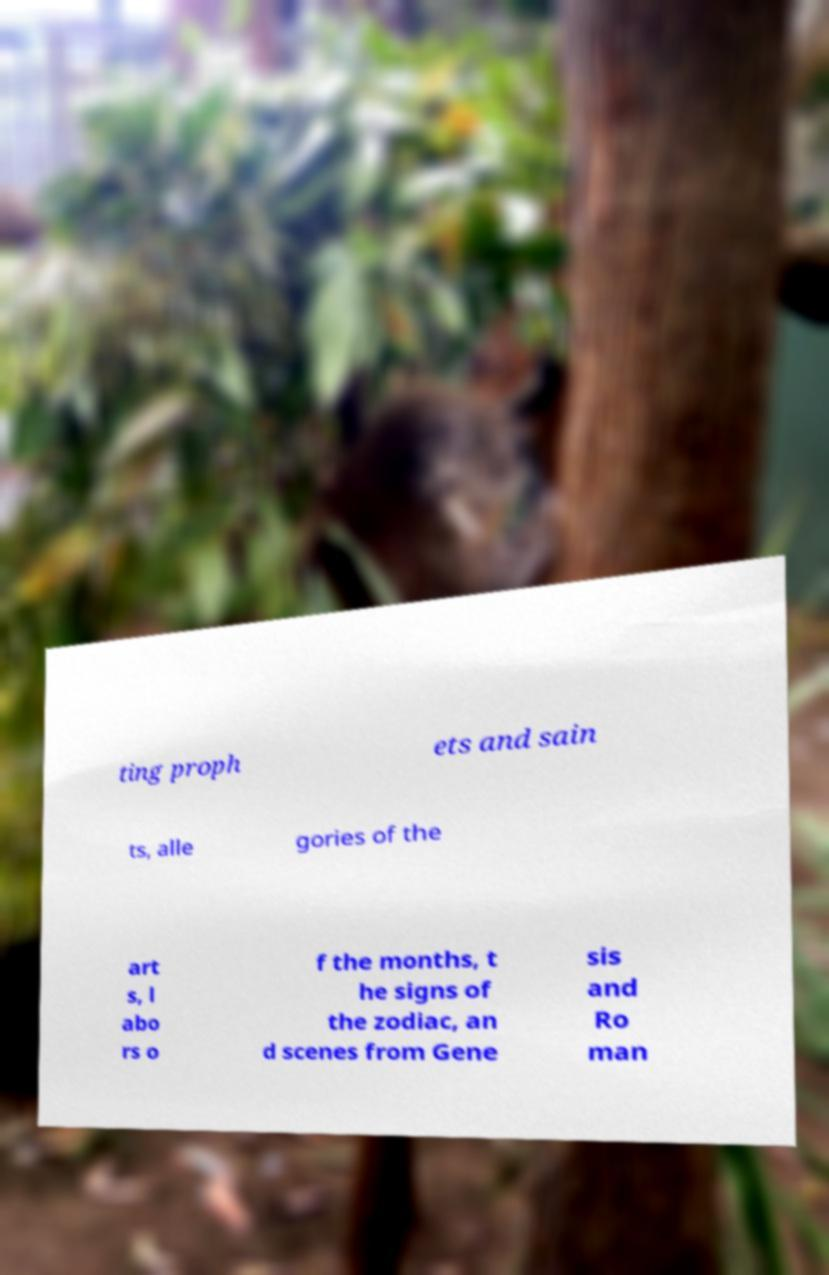Could you assist in decoding the text presented in this image and type it out clearly? ting proph ets and sain ts, alle gories of the art s, l abo rs o f the months, t he signs of the zodiac, an d scenes from Gene sis and Ro man 